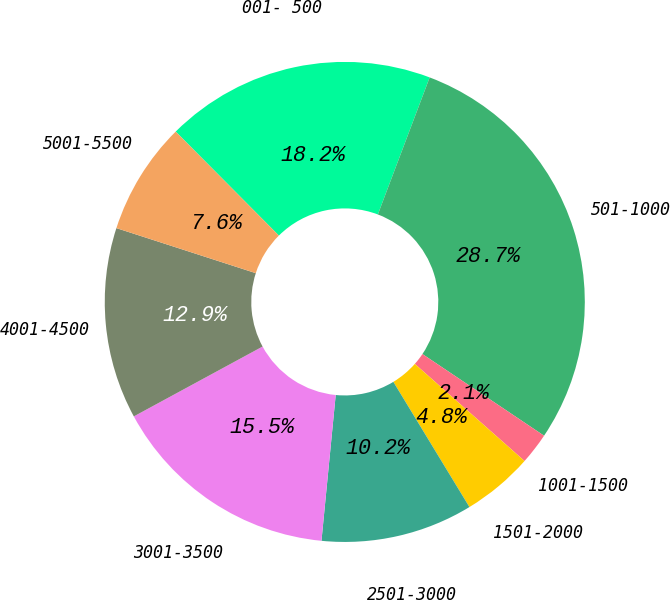<chart> <loc_0><loc_0><loc_500><loc_500><pie_chart><fcel>001- 500<fcel>501-1000<fcel>1001-1500<fcel>1501-2000<fcel>2501-3000<fcel>3001-3500<fcel>4001-4500<fcel>5001-5500<nl><fcel>18.2%<fcel>28.66%<fcel>2.12%<fcel>4.78%<fcel>10.24%<fcel>15.54%<fcel>12.89%<fcel>7.58%<nl></chart> 